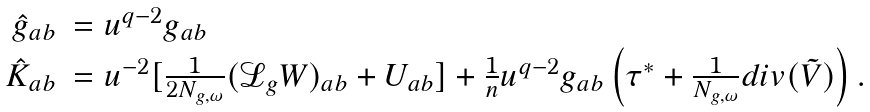<formula> <loc_0><loc_0><loc_500><loc_500>\begin{array} { r l } \hat { g } _ { a b } & = u ^ { q - 2 } g _ { a b } \\ \hat { K } _ { a b } & = u ^ { - 2 } [ \frac { 1 } { 2 N _ { g , \omega } } ( \mathcal { L } _ { g } W ) _ { a b } + U _ { a b } ] + \frac { 1 } { n } u ^ { q - 2 } g _ { a b } \left ( \tau ^ { * } + \frac { 1 } { N _ { g , \omega } } d i v ( \tilde { V } ) \right ) . \end{array}</formula> 